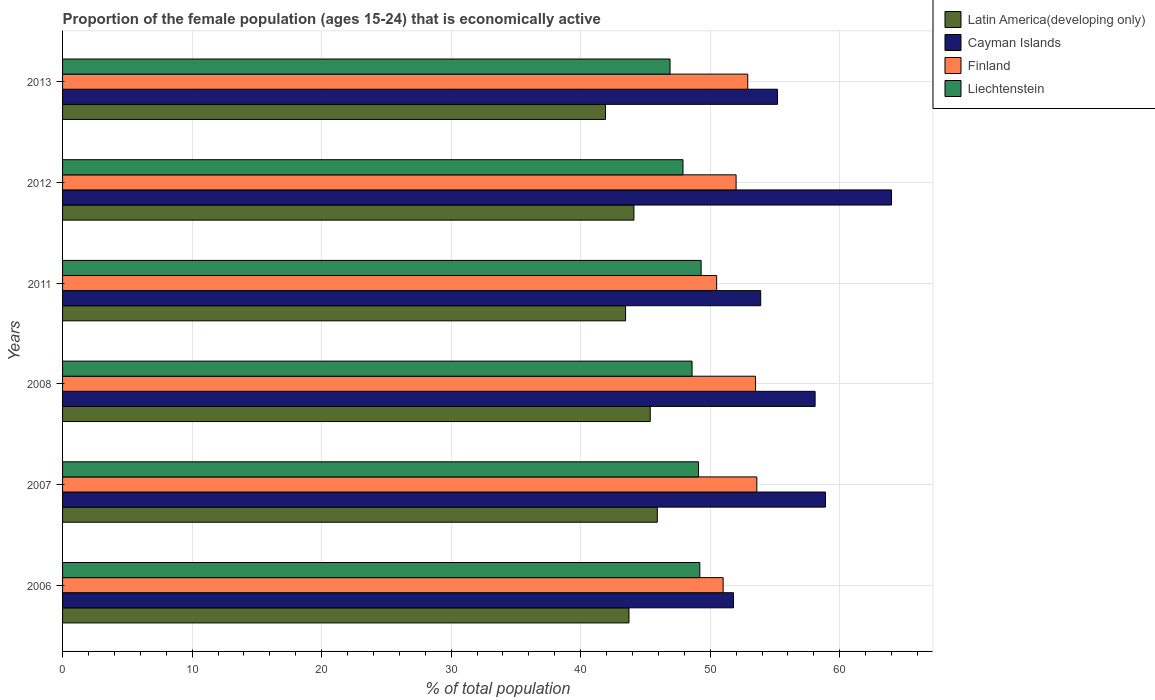How many different coloured bars are there?
Make the answer very short. 4. How many groups of bars are there?
Make the answer very short. 6. Are the number of bars on each tick of the Y-axis equal?
Offer a terse response. Yes. What is the label of the 2nd group of bars from the top?
Provide a short and direct response. 2012. In how many cases, is the number of bars for a given year not equal to the number of legend labels?
Provide a short and direct response. 0. What is the proportion of the female population that is economically active in Liechtenstein in 2007?
Your response must be concise. 49.1. Across all years, what is the minimum proportion of the female population that is economically active in Cayman Islands?
Provide a short and direct response. 51.8. In which year was the proportion of the female population that is economically active in Liechtenstein minimum?
Offer a very short reply. 2013. What is the total proportion of the female population that is economically active in Finland in the graph?
Give a very brief answer. 313.5. What is the difference between the proportion of the female population that is economically active in Cayman Islands in 2006 and that in 2011?
Ensure brevity in your answer.  -2.1. What is the difference between the proportion of the female population that is economically active in Cayman Islands in 2008 and the proportion of the female population that is economically active in Finland in 2013?
Offer a very short reply. 5.2. What is the average proportion of the female population that is economically active in Cayman Islands per year?
Provide a succinct answer. 56.98. In the year 2013, what is the difference between the proportion of the female population that is economically active in Latin America(developing only) and proportion of the female population that is economically active in Finland?
Give a very brief answer. -10.98. What is the ratio of the proportion of the female population that is economically active in Cayman Islands in 2006 to that in 2013?
Keep it short and to the point. 0.94. Is the proportion of the female population that is economically active in Latin America(developing only) in 2006 less than that in 2007?
Your answer should be very brief. Yes. What is the difference between the highest and the second highest proportion of the female population that is economically active in Finland?
Offer a very short reply. 0.1. What is the difference between the highest and the lowest proportion of the female population that is economically active in Liechtenstein?
Ensure brevity in your answer.  2.4. What does the 4th bar from the top in 2011 represents?
Provide a short and direct response. Latin America(developing only). What does the 2nd bar from the bottom in 2013 represents?
Offer a terse response. Cayman Islands. Is it the case that in every year, the sum of the proportion of the female population that is economically active in Latin America(developing only) and proportion of the female population that is economically active in Cayman Islands is greater than the proportion of the female population that is economically active in Liechtenstein?
Your response must be concise. Yes. Does the graph contain any zero values?
Your response must be concise. No. Does the graph contain grids?
Provide a short and direct response. Yes. Where does the legend appear in the graph?
Ensure brevity in your answer.  Top right. How many legend labels are there?
Keep it short and to the point. 4. How are the legend labels stacked?
Provide a succinct answer. Vertical. What is the title of the graph?
Your answer should be very brief. Proportion of the female population (ages 15-24) that is economically active. Does "Turkmenistan" appear as one of the legend labels in the graph?
Keep it short and to the point. No. What is the label or title of the X-axis?
Ensure brevity in your answer.  % of total population. What is the % of total population of Latin America(developing only) in 2006?
Offer a very short reply. 43.73. What is the % of total population of Cayman Islands in 2006?
Your response must be concise. 51.8. What is the % of total population of Liechtenstein in 2006?
Your answer should be very brief. 49.2. What is the % of total population of Latin America(developing only) in 2007?
Your answer should be very brief. 45.92. What is the % of total population in Cayman Islands in 2007?
Make the answer very short. 58.9. What is the % of total population of Finland in 2007?
Offer a terse response. 53.6. What is the % of total population of Liechtenstein in 2007?
Provide a short and direct response. 49.1. What is the % of total population in Latin America(developing only) in 2008?
Your response must be concise. 45.37. What is the % of total population in Cayman Islands in 2008?
Your answer should be compact. 58.1. What is the % of total population in Finland in 2008?
Your answer should be compact. 53.5. What is the % of total population of Liechtenstein in 2008?
Keep it short and to the point. 48.6. What is the % of total population of Latin America(developing only) in 2011?
Ensure brevity in your answer.  43.47. What is the % of total population of Cayman Islands in 2011?
Your answer should be compact. 53.9. What is the % of total population in Finland in 2011?
Ensure brevity in your answer.  50.5. What is the % of total population in Liechtenstein in 2011?
Keep it short and to the point. 49.3. What is the % of total population in Latin America(developing only) in 2012?
Keep it short and to the point. 44.11. What is the % of total population in Cayman Islands in 2012?
Offer a very short reply. 64. What is the % of total population of Finland in 2012?
Ensure brevity in your answer.  52. What is the % of total population in Liechtenstein in 2012?
Ensure brevity in your answer.  47.9. What is the % of total population in Latin America(developing only) in 2013?
Offer a very short reply. 41.92. What is the % of total population in Cayman Islands in 2013?
Your answer should be very brief. 55.2. What is the % of total population of Finland in 2013?
Make the answer very short. 52.9. What is the % of total population in Liechtenstein in 2013?
Offer a very short reply. 46.9. Across all years, what is the maximum % of total population of Latin America(developing only)?
Make the answer very short. 45.92. Across all years, what is the maximum % of total population in Cayman Islands?
Your answer should be compact. 64. Across all years, what is the maximum % of total population in Finland?
Give a very brief answer. 53.6. Across all years, what is the maximum % of total population of Liechtenstein?
Your answer should be compact. 49.3. Across all years, what is the minimum % of total population of Latin America(developing only)?
Ensure brevity in your answer.  41.92. Across all years, what is the minimum % of total population of Cayman Islands?
Give a very brief answer. 51.8. Across all years, what is the minimum % of total population of Finland?
Provide a short and direct response. 50.5. Across all years, what is the minimum % of total population in Liechtenstein?
Your response must be concise. 46.9. What is the total % of total population in Latin America(developing only) in the graph?
Give a very brief answer. 264.52. What is the total % of total population in Cayman Islands in the graph?
Ensure brevity in your answer.  341.9. What is the total % of total population in Finland in the graph?
Your answer should be compact. 313.5. What is the total % of total population in Liechtenstein in the graph?
Keep it short and to the point. 291. What is the difference between the % of total population in Latin America(developing only) in 2006 and that in 2007?
Your response must be concise. -2.19. What is the difference between the % of total population of Cayman Islands in 2006 and that in 2007?
Provide a short and direct response. -7.1. What is the difference between the % of total population in Latin America(developing only) in 2006 and that in 2008?
Keep it short and to the point. -1.64. What is the difference between the % of total population of Cayman Islands in 2006 and that in 2008?
Your response must be concise. -6.3. What is the difference between the % of total population in Finland in 2006 and that in 2008?
Offer a very short reply. -2.5. What is the difference between the % of total population in Latin America(developing only) in 2006 and that in 2011?
Provide a short and direct response. 0.26. What is the difference between the % of total population in Cayman Islands in 2006 and that in 2011?
Your answer should be very brief. -2.1. What is the difference between the % of total population in Finland in 2006 and that in 2011?
Provide a succinct answer. 0.5. What is the difference between the % of total population of Liechtenstein in 2006 and that in 2011?
Ensure brevity in your answer.  -0.1. What is the difference between the % of total population in Latin America(developing only) in 2006 and that in 2012?
Your answer should be very brief. -0.38. What is the difference between the % of total population of Finland in 2006 and that in 2012?
Provide a succinct answer. -1. What is the difference between the % of total population of Liechtenstein in 2006 and that in 2012?
Offer a terse response. 1.3. What is the difference between the % of total population in Latin America(developing only) in 2006 and that in 2013?
Offer a very short reply. 1.81. What is the difference between the % of total population in Cayman Islands in 2006 and that in 2013?
Your answer should be very brief. -3.4. What is the difference between the % of total population in Liechtenstein in 2006 and that in 2013?
Provide a succinct answer. 2.3. What is the difference between the % of total population of Latin America(developing only) in 2007 and that in 2008?
Ensure brevity in your answer.  0.55. What is the difference between the % of total population of Cayman Islands in 2007 and that in 2008?
Your response must be concise. 0.8. What is the difference between the % of total population in Finland in 2007 and that in 2008?
Make the answer very short. 0.1. What is the difference between the % of total population of Latin America(developing only) in 2007 and that in 2011?
Offer a terse response. 2.45. What is the difference between the % of total population of Cayman Islands in 2007 and that in 2011?
Ensure brevity in your answer.  5. What is the difference between the % of total population in Latin America(developing only) in 2007 and that in 2012?
Provide a short and direct response. 1.81. What is the difference between the % of total population in Cayman Islands in 2007 and that in 2012?
Offer a very short reply. -5.1. What is the difference between the % of total population in Liechtenstein in 2007 and that in 2012?
Your response must be concise. 1.2. What is the difference between the % of total population of Latin America(developing only) in 2007 and that in 2013?
Offer a terse response. 4. What is the difference between the % of total population in Cayman Islands in 2007 and that in 2013?
Your answer should be compact. 3.7. What is the difference between the % of total population of Liechtenstein in 2007 and that in 2013?
Offer a terse response. 2.2. What is the difference between the % of total population of Latin America(developing only) in 2008 and that in 2011?
Keep it short and to the point. 1.91. What is the difference between the % of total population of Cayman Islands in 2008 and that in 2011?
Give a very brief answer. 4.2. What is the difference between the % of total population in Finland in 2008 and that in 2011?
Offer a very short reply. 3. What is the difference between the % of total population in Latin America(developing only) in 2008 and that in 2012?
Provide a short and direct response. 1.26. What is the difference between the % of total population in Liechtenstein in 2008 and that in 2012?
Make the answer very short. 0.7. What is the difference between the % of total population of Latin America(developing only) in 2008 and that in 2013?
Your answer should be compact. 3.46. What is the difference between the % of total population of Liechtenstein in 2008 and that in 2013?
Provide a short and direct response. 1.7. What is the difference between the % of total population in Latin America(developing only) in 2011 and that in 2012?
Offer a terse response. -0.64. What is the difference between the % of total population in Cayman Islands in 2011 and that in 2012?
Give a very brief answer. -10.1. What is the difference between the % of total population in Finland in 2011 and that in 2012?
Ensure brevity in your answer.  -1.5. What is the difference between the % of total population in Latin America(developing only) in 2011 and that in 2013?
Your response must be concise. 1.55. What is the difference between the % of total population of Cayman Islands in 2011 and that in 2013?
Offer a very short reply. -1.3. What is the difference between the % of total population of Liechtenstein in 2011 and that in 2013?
Ensure brevity in your answer.  2.4. What is the difference between the % of total population of Latin America(developing only) in 2012 and that in 2013?
Make the answer very short. 2.2. What is the difference between the % of total population in Cayman Islands in 2012 and that in 2013?
Offer a terse response. 8.8. What is the difference between the % of total population in Finland in 2012 and that in 2013?
Offer a very short reply. -0.9. What is the difference between the % of total population of Liechtenstein in 2012 and that in 2013?
Provide a short and direct response. 1. What is the difference between the % of total population in Latin America(developing only) in 2006 and the % of total population in Cayman Islands in 2007?
Your response must be concise. -15.17. What is the difference between the % of total population of Latin America(developing only) in 2006 and the % of total population of Finland in 2007?
Your answer should be very brief. -9.87. What is the difference between the % of total population of Latin America(developing only) in 2006 and the % of total population of Liechtenstein in 2007?
Give a very brief answer. -5.37. What is the difference between the % of total population of Cayman Islands in 2006 and the % of total population of Liechtenstein in 2007?
Provide a short and direct response. 2.7. What is the difference between the % of total population in Finland in 2006 and the % of total population in Liechtenstein in 2007?
Your answer should be very brief. 1.9. What is the difference between the % of total population of Latin America(developing only) in 2006 and the % of total population of Cayman Islands in 2008?
Ensure brevity in your answer.  -14.37. What is the difference between the % of total population of Latin America(developing only) in 2006 and the % of total population of Finland in 2008?
Ensure brevity in your answer.  -9.77. What is the difference between the % of total population in Latin America(developing only) in 2006 and the % of total population in Liechtenstein in 2008?
Your answer should be compact. -4.87. What is the difference between the % of total population of Finland in 2006 and the % of total population of Liechtenstein in 2008?
Make the answer very short. 2.4. What is the difference between the % of total population in Latin America(developing only) in 2006 and the % of total population in Cayman Islands in 2011?
Provide a succinct answer. -10.17. What is the difference between the % of total population of Latin America(developing only) in 2006 and the % of total population of Finland in 2011?
Offer a terse response. -6.77. What is the difference between the % of total population in Latin America(developing only) in 2006 and the % of total population in Liechtenstein in 2011?
Make the answer very short. -5.57. What is the difference between the % of total population of Cayman Islands in 2006 and the % of total population of Liechtenstein in 2011?
Make the answer very short. 2.5. What is the difference between the % of total population of Latin America(developing only) in 2006 and the % of total population of Cayman Islands in 2012?
Provide a succinct answer. -20.27. What is the difference between the % of total population of Latin America(developing only) in 2006 and the % of total population of Finland in 2012?
Offer a very short reply. -8.27. What is the difference between the % of total population of Latin America(developing only) in 2006 and the % of total population of Liechtenstein in 2012?
Make the answer very short. -4.17. What is the difference between the % of total population in Finland in 2006 and the % of total population in Liechtenstein in 2012?
Ensure brevity in your answer.  3.1. What is the difference between the % of total population in Latin America(developing only) in 2006 and the % of total population in Cayman Islands in 2013?
Ensure brevity in your answer.  -11.47. What is the difference between the % of total population in Latin America(developing only) in 2006 and the % of total population in Finland in 2013?
Your answer should be very brief. -9.17. What is the difference between the % of total population of Latin America(developing only) in 2006 and the % of total population of Liechtenstein in 2013?
Ensure brevity in your answer.  -3.17. What is the difference between the % of total population of Cayman Islands in 2006 and the % of total population of Finland in 2013?
Make the answer very short. -1.1. What is the difference between the % of total population of Latin America(developing only) in 2007 and the % of total population of Cayman Islands in 2008?
Give a very brief answer. -12.18. What is the difference between the % of total population in Latin America(developing only) in 2007 and the % of total population in Finland in 2008?
Give a very brief answer. -7.58. What is the difference between the % of total population in Latin America(developing only) in 2007 and the % of total population in Liechtenstein in 2008?
Give a very brief answer. -2.68. What is the difference between the % of total population in Cayman Islands in 2007 and the % of total population in Liechtenstein in 2008?
Offer a very short reply. 10.3. What is the difference between the % of total population of Finland in 2007 and the % of total population of Liechtenstein in 2008?
Make the answer very short. 5. What is the difference between the % of total population of Latin America(developing only) in 2007 and the % of total population of Cayman Islands in 2011?
Provide a short and direct response. -7.98. What is the difference between the % of total population in Latin America(developing only) in 2007 and the % of total population in Finland in 2011?
Make the answer very short. -4.58. What is the difference between the % of total population in Latin America(developing only) in 2007 and the % of total population in Liechtenstein in 2011?
Your answer should be very brief. -3.38. What is the difference between the % of total population of Finland in 2007 and the % of total population of Liechtenstein in 2011?
Provide a succinct answer. 4.3. What is the difference between the % of total population of Latin America(developing only) in 2007 and the % of total population of Cayman Islands in 2012?
Make the answer very short. -18.08. What is the difference between the % of total population of Latin America(developing only) in 2007 and the % of total population of Finland in 2012?
Provide a succinct answer. -6.08. What is the difference between the % of total population in Latin America(developing only) in 2007 and the % of total population in Liechtenstein in 2012?
Keep it short and to the point. -1.98. What is the difference between the % of total population in Finland in 2007 and the % of total population in Liechtenstein in 2012?
Offer a terse response. 5.7. What is the difference between the % of total population of Latin America(developing only) in 2007 and the % of total population of Cayman Islands in 2013?
Your answer should be very brief. -9.28. What is the difference between the % of total population in Latin America(developing only) in 2007 and the % of total population in Finland in 2013?
Ensure brevity in your answer.  -6.98. What is the difference between the % of total population of Latin America(developing only) in 2007 and the % of total population of Liechtenstein in 2013?
Your answer should be very brief. -0.98. What is the difference between the % of total population in Latin America(developing only) in 2008 and the % of total population in Cayman Islands in 2011?
Ensure brevity in your answer.  -8.53. What is the difference between the % of total population in Latin America(developing only) in 2008 and the % of total population in Finland in 2011?
Provide a succinct answer. -5.13. What is the difference between the % of total population in Latin America(developing only) in 2008 and the % of total population in Liechtenstein in 2011?
Ensure brevity in your answer.  -3.93. What is the difference between the % of total population in Cayman Islands in 2008 and the % of total population in Finland in 2011?
Your answer should be very brief. 7.6. What is the difference between the % of total population in Cayman Islands in 2008 and the % of total population in Liechtenstein in 2011?
Ensure brevity in your answer.  8.8. What is the difference between the % of total population in Finland in 2008 and the % of total population in Liechtenstein in 2011?
Ensure brevity in your answer.  4.2. What is the difference between the % of total population of Latin America(developing only) in 2008 and the % of total population of Cayman Islands in 2012?
Offer a terse response. -18.63. What is the difference between the % of total population of Latin America(developing only) in 2008 and the % of total population of Finland in 2012?
Provide a short and direct response. -6.63. What is the difference between the % of total population of Latin America(developing only) in 2008 and the % of total population of Liechtenstein in 2012?
Provide a succinct answer. -2.53. What is the difference between the % of total population of Cayman Islands in 2008 and the % of total population of Finland in 2012?
Keep it short and to the point. 6.1. What is the difference between the % of total population of Cayman Islands in 2008 and the % of total population of Liechtenstein in 2012?
Keep it short and to the point. 10.2. What is the difference between the % of total population in Latin America(developing only) in 2008 and the % of total population in Cayman Islands in 2013?
Offer a terse response. -9.83. What is the difference between the % of total population of Latin America(developing only) in 2008 and the % of total population of Finland in 2013?
Offer a terse response. -7.53. What is the difference between the % of total population of Latin America(developing only) in 2008 and the % of total population of Liechtenstein in 2013?
Offer a very short reply. -1.53. What is the difference between the % of total population of Finland in 2008 and the % of total population of Liechtenstein in 2013?
Keep it short and to the point. 6.6. What is the difference between the % of total population of Latin America(developing only) in 2011 and the % of total population of Cayman Islands in 2012?
Offer a terse response. -20.53. What is the difference between the % of total population in Latin America(developing only) in 2011 and the % of total population in Finland in 2012?
Ensure brevity in your answer.  -8.53. What is the difference between the % of total population in Latin America(developing only) in 2011 and the % of total population in Liechtenstein in 2012?
Ensure brevity in your answer.  -4.43. What is the difference between the % of total population of Cayman Islands in 2011 and the % of total population of Finland in 2012?
Your answer should be very brief. 1.9. What is the difference between the % of total population in Latin America(developing only) in 2011 and the % of total population in Cayman Islands in 2013?
Keep it short and to the point. -11.73. What is the difference between the % of total population in Latin America(developing only) in 2011 and the % of total population in Finland in 2013?
Your answer should be very brief. -9.43. What is the difference between the % of total population of Latin America(developing only) in 2011 and the % of total population of Liechtenstein in 2013?
Offer a very short reply. -3.43. What is the difference between the % of total population in Cayman Islands in 2011 and the % of total population in Finland in 2013?
Make the answer very short. 1. What is the difference between the % of total population of Cayman Islands in 2011 and the % of total population of Liechtenstein in 2013?
Make the answer very short. 7. What is the difference between the % of total population of Finland in 2011 and the % of total population of Liechtenstein in 2013?
Your answer should be compact. 3.6. What is the difference between the % of total population of Latin America(developing only) in 2012 and the % of total population of Cayman Islands in 2013?
Make the answer very short. -11.09. What is the difference between the % of total population of Latin America(developing only) in 2012 and the % of total population of Finland in 2013?
Make the answer very short. -8.79. What is the difference between the % of total population in Latin America(developing only) in 2012 and the % of total population in Liechtenstein in 2013?
Your answer should be very brief. -2.79. What is the difference between the % of total population of Cayman Islands in 2012 and the % of total population of Finland in 2013?
Ensure brevity in your answer.  11.1. What is the difference between the % of total population of Cayman Islands in 2012 and the % of total population of Liechtenstein in 2013?
Provide a short and direct response. 17.1. What is the average % of total population of Latin America(developing only) per year?
Your answer should be compact. 44.09. What is the average % of total population in Cayman Islands per year?
Your answer should be compact. 56.98. What is the average % of total population in Finland per year?
Ensure brevity in your answer.  52.25. What is the average % of total population of Liechtenstein per year?
Your response must be concise. 48.5. In the year 2006, what is the difference between the % of total population of Latin America(developing only) and % of total population of Cayman Islands?
Provide a short and direct response. -8.07. In the year 2006, what is the difference between the % of total population in Latin America(developing only) and % of total population in Finland?
Give a very brief answer. -7.27. In the year 2006, what is the difference between the % of total population in Latin America(developing only) and % of total population in Liechtenstein?
Provide a succinct answer. -5.47. In the year 2006, what is the difference between the % of total population in Finland and % of total population in Liechtenstein?
Offer a very short reply. 1.8. In the year 2007, what is the difference between the % of total population in Latin America(developing only) and % of total population in Cayman Islands?
Offer a very short reply. -12.98. In the year 2007, what is the difference between the % of total population in Latin America(developing only) and % of total population in Finland?
Provide a short and direct response. -7.68. In the year 2007, what is the difference between the % of total population in Latin America(developing only) and % of total population in Liechtenstein?
Ensure brevity in your answer.  -3.18. In the year 2007, what is the difference between the % of total population in Cayman Islands and % of total population in Finland?
Ensure brevity in your answer.  5.3. In the year 2007, what is the difference between the % of total population of Cayman Islands and % of total population of Liechtenstein?
Provide a succinct answer. 9.8. In the year 2007, what is the difference between the % of total population in Finland and % of total population in Liechtenstein?
Provide a succinct answer. 4.5. In the year 2008, what is the difference between the % of total population in Latin America(developing only) and % of total population in Cayman Islands?
Provide a succinct answer. -12.73. In the year 2008, what is the difference between the % of total population of Latin America(developing only) and % of total population of Finland?
Keep it short and to the point. -8.13. In the year 2008, what is the difference between the % of total population of Latin America(developing only) and % of total population of Liechtenstein?
Your response must be concise. -3.23. In the year 2008, what is the difference between the % of total population of Cayman Islands and % of total population of Finland?
Ensure brevity in your answer.  4.6. In the year 2008, what is the difference between the % of total population in Finland and % of total population in Liechtenstein?
Your answer should be compact. 4.9. In the year 2011, what is the difference between the % of total population in Latin America(developing only) and % of total population in Cayman Islands?
Your answer should be compact. -10.43. In the year 2011, what is the difference between the % of total population in Latin America(developing only) and % of total population in Finland?
Your response must be concise. -7.03. In the year 2011, what is the difference between the % of total population in Latin America(developing only) and % of total population in Liechtenstein?
Your answer should be very brief. -5.83. In the year 2011, what is the difference between the % of total population of Cayman Islands and % of total population of Liechtenstein?
Your response must be concise. 4.6. In the year 2012, what is the difference between the % of total population in Latin America(developing only) and % of total population in Cayman Islands?
Give a very brief answer. -19.89. In the year 2012, what is the difference between the % of total population in Latin America(developing only) and % of total population in Finland?
Offer a terse response. -7.89. In the year 2012, what is the difference between the % of total population in Latin America(developing only) and % of total population in Liechtenstein?
Your answer should be very brief. -3.79. In the year 2012, what is the difference between the % of total population in Cayman Islands and % of total population in Finland?
Ensure brevity in your answer.  12. In the year 2012, what is the difference between the % of total population of Cayman Islands and % of total population of Liechtenstein?
Ensure brevity in your answer.  16.1. In the year 2013, what is the difference between the % of total population of Latin America(developing only) and % of total population of Cayman Islands?
Offer a terse response. -13.28. In the year 2013, what is the difference between the % of total population in Latin America(developing only) and % of total population in Finland?
Your response must be concise. -10.98. In the year 2013, what is the difference between the % of total population of Latin America(developing only) and % of total population of Liechtenstein?
Offer a terse response. -4.98. In the year 2013, what is the difference between the % of total population of Cayman Islands and % of total population of Liechtenstein?
Your answer should be compact. 8.3. In the year 2013, what is the difference between the % of total population of Finland and % of total population of Liechtenstein?
Your answer should be compact. 6. What is the ratio of the % of total population in Cayman Islands in 2006 to that in 2007?
Offer a terse response. 0.88. What is the ratio of the % of total population of Finland in 2006 to that in 2007?
Give a very brief answer. 0.95. What is the ratio of the % of total population in Latin America(developing only) in 2006 to that in 2008?
Give a very brief answer. 0.96. What is the ratio of the % of total population of Cayman Islands in 2006 to that in 2008?
Your response must be concise. 0.89. What is the ratio of the % of total population in Finland in 2006 to that in 2008?
Make the answer very short. 0.95. What is the ratio of the % of total population of Liechtenstein in 2006 to that in 2008?
Ensure brevity in your answer.  1.01. What is the ratio of the % of total population in Latin America(developing only) in 2006 to that in 2011?
Keep it short and to the point. 1.01. What is the ratio of the % of total population of Cayman Islands in 2006 to that in 2011?
Your response must be concise. 0.96. What is the ratio of the % of total population of Finland in 2006 to that in 2011?
Give a very brief answer. 1.01. What is the ratio of the % of total population in Liechtenstein in 2006 to that in 2011?
Give a very brief answer. 1. What is the ratio of the % of total population of Cayman Islands in 2006 to that in 2012?
Your answer should be compact. 0.81. What is the ratio of the % of total population in Finland in 2006 to that in 2012?
Make the answer very short. 0.98. What is the ratio of the % of total population in Liechtenstein in 2006 to that in 2012?
Your answer should be very brief. 1.03. What is the ratio of the % of total population of Latin America(developing only) in 2006 to that in 2013?
Give a very brief answer. 1.04. What is the ratio of the % of total population in Cayman Islands in 2006 to that in 2013?
Provide a short and direct response. 0.94. What is the ratio of the % of total population of Finland in 2006 to that in 2013?
Provide a succinct answer. 0.96. What is the ratio of the % of total population in Liechtenstein in 2006 to that in 2013?
Keep it short and to the point. 1.05. What is the ratio of the % of total population of Cayman Islands in 2007 to that in 2008?
Make the answer very short. 1.01. What is the ratio of the % of total population in Finland in 2007 to that in 2008?
Keep it short and to the point. 1. What is the ratio of the % of total population of Liechtenstein in 2007 to that in 2008?
Provide a succinct answer. 1.01. What is the ratio of the % of total population of Latin America(developing only) in 2007 to that in 2011?
Your answer should be compact. 1.06. What is the ratio of the % of total population of Cayman Islands in 2007 to that in 2011?
Offer a terse response. 1.09. What is the ratio of the % of total population in Finland in 2007 to that in 2011?
Offer a very short reply. 1.06. What is the ratio of the % of total population of Liechtenstein in 2007 to that in 2011?
Your answer should be very brief. 1. What is the ratio of the % of total population in Latin America(developing only) in 2007 to that in 2012?
Provide a short and direct response. 1.04. What is the ratio of the % of total population of Cayman Islands in 2007 to that in 2012?
Give a very brief answer. 0.92. What is the ratio of the % of total population in Finland in 2007 to that in 2012?
Offer a terse response. 1.03. What is the ratio of the % of total population of Liechtenstein in 2007 to that in 2012?
Offer a very short reply. 1.03. What is the ratio of the % of total population in Latin America(developing only) in 2007 to that in 2013?
Give a very brief answer. 1.1. What is the ratio of the % of total population in Cayman Islands in 2007 to that in 2013?
Keep it short and to the point. 1.07. What is the ratio of the % of total population of Finland in 2007 to that in 2013?
Your answer should be very brief. 1.01. What is the ratio of the % of total population in Liechtenstein in 2007 to that in 2013?
Offer a very short reply. 1.05. What is the ratio of the % of total population in Latin America(developing only) in 2008 to that in 2011?
Offer a terse response. 1.04. What is the ratio of the % of total population in Cayman Islands in 2008 to that in 2011?
Your answer should be compact. 1.08. What is the ratio of the % of total population of Finland in 2008 to that in 2011?
Make the answer very short. 1.06. What is the ratio of the % of total population in Liechtenstein in 2008 to that in 2011?
Keep it short and to the point. 0.99. What is the ratio of the % of total population of Latin America(developing only) in 2008 to that in 2012?
Your answer should be very brief. 1.03. What is the ratio of the % of total population in Cayman Islands in 2008 to that in 2012?
Your response must be concise. 0.91. What is the ratio of the % of total population of Finland in 2008 to that in 2012?
Your answer should be compact. 1.03. What is the ratio of the % of total population of Liechtenstein in 2008 to that in 2012?
Give a very brief answer. 1.01. What is the ratio of the % of total population of Latin America(developing only) in 2008 to that in 2013?
Your answer should be very brief. 1.08. What is the ratio of the % of total population in Cayman Islands in 2008 to that in 2013?
Ensure brevity in your answer.  1.05. What is the ratio of the % of total population of Finland in 2008 to that in 2013?
Offer a terse response. 1.01. What is the ratio of the % of total population in Liechtenstein in 2008 to that in 2013?
Ensure brevity in your answer.  1.04. What is the ratio of the % of total population in Latin America(developing only) in 2011 to that in 2012?
Make the answer very short. 0.99. What is the ratio of the % of total population of Cayman Islands in 2011 to that in 2012?
Give a very brief answer. 0.84. What is the ratio of the % of total population in Finland in 2011 to that in 2012?
Offer a very short reply. 0.97. What is the ratio of the % of total population in Liechtenstein in 2011 to that in 2012?
Your answer should be compact. 1.03. What is the ratio of the % of total population in Latin America(developing only) in 2011 to that in 2013?
Provide a short and direct response. 1.04. What is the ratio of the % of total population in Cayman Islands in 2011 to that in 2013?
Provide a succinct answer. 0.98. What is the ratio of the % of total population in Finland in 2011 to that in 2013?
Ensure brevity in your answer.  0.95. What is the ratio of the % of total population in Liechtenstein in 2011 to that in 2013?
Give a very brief answer. 1.05. What is the ratio of the % of total population in Latin America(developing only) in 2012 to that in 2013?
Give a very brief answer. 1.05. What is the ratio of the % of total population of Cayman Islands in 2012 to that in 2013?
Provide a succinct answer. 1.16. What is the ratio of the % of total population of Liechtenstein in 2012 to that in 2013?
Make the answer very short. 1.02. What is the difference between the highest and the second highest % of total population of Latin America(developing only)?
Offer a terse response. 0.55. What is the difference between the highest and the second highest % of total population of Cayman Islands?
Your response must be concise. 5.1. What is the difference between the highest and the lowest % of total population of Latin America(developing only)?
Give a very brief answer. 4. What is the difference between the highest and the lowest % of total population in Cayman Islands?
Provide a short and direct response. 12.2. What is the difference between the highest and the lowest % of total population of Finland?
Offer a very short reply. 3.1. 